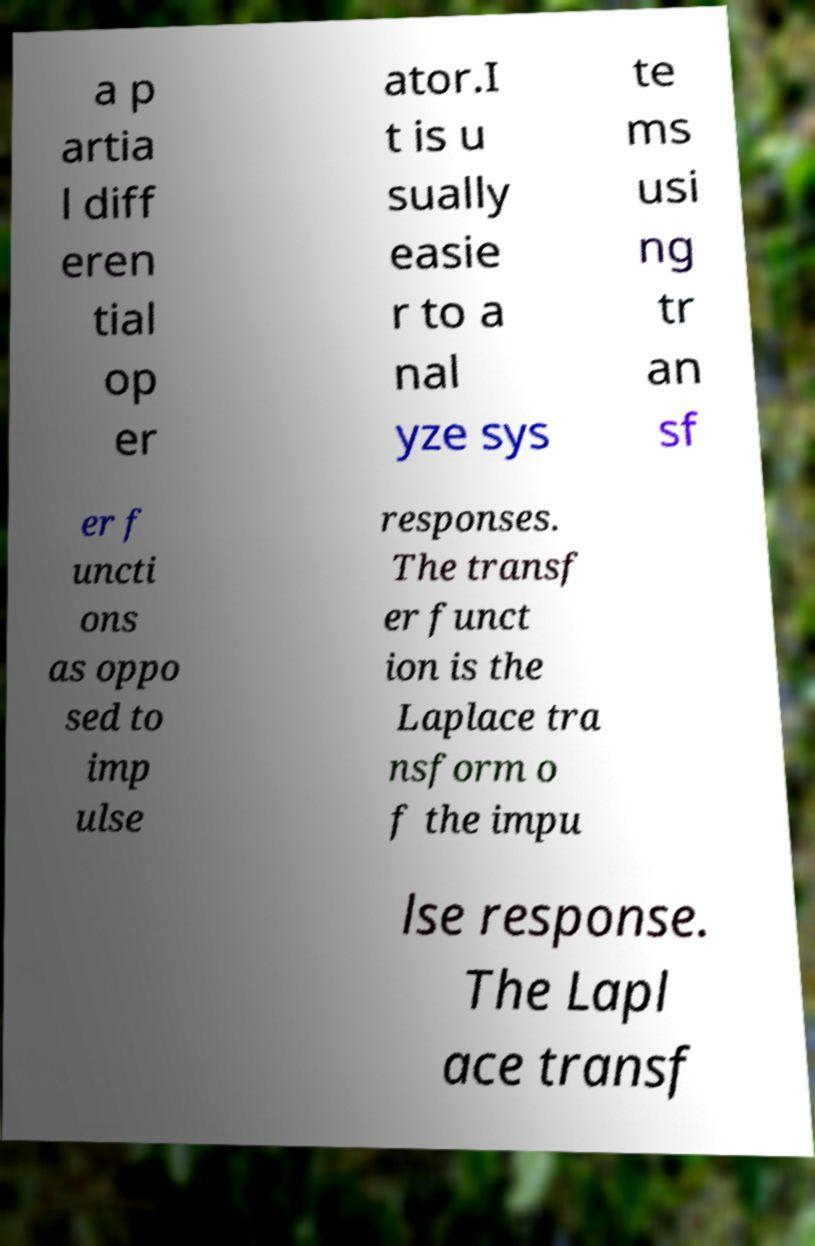Can you read and provide the text displayed in the image?This photo seems to have some interesting text. Can you extract and type it out for me? a p artia l diff eren tial op er ator.I t is u sually easie r to a nal yze sys te ms usi ng tr an sf er f uncti ons as oppo sed to imp ulse responses. The transf er funct ion is the Laplace tra nsform o f the impu lse response. The Lapl ace transf 